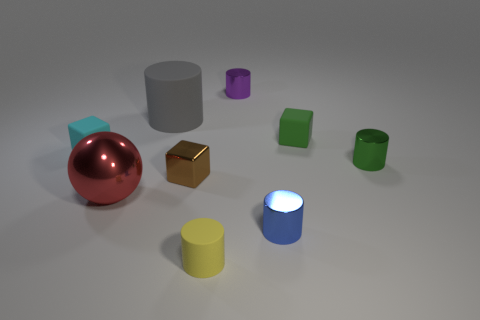If we imagine these objects represent a mini city, can you describe what each object might be? In a mini city scenario, the red sphere could be a central town hall due to its prominent and central position. The gold cube might be a luxury building, considering its lustrous appearance. The various cylinders could be industrial silos, and the blocks might represent residential and commercial buildings due to their blocky, pragmatic design. 